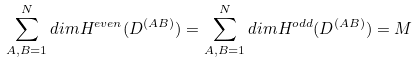<formula> <loc_0><loc_0><loc_500><loc_500>\sum _ { A , B = 1 } ^ { N } d i m H ^ { e v e n } ( D ^ { ( A B ) } ) = \sum _ { A , B = 1 } ^ { N } d i m H ^ { o d d } ( D ^ { ( A B ) } ) = M</formula> 